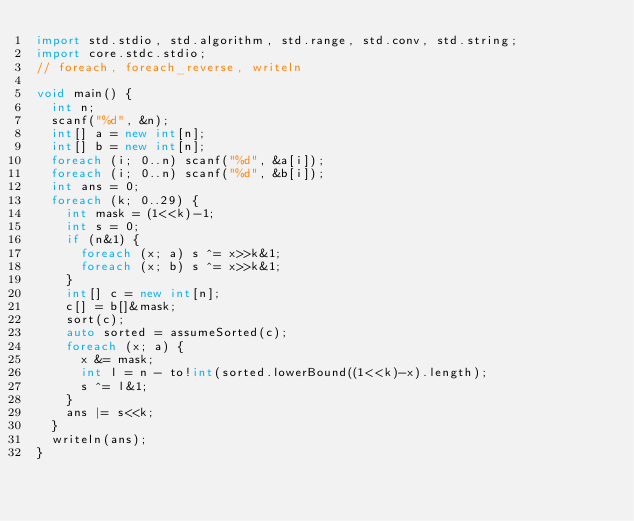Convert code to text. <code><loc_0><loc_0><loc_500><loc_500><_D_>import std.stdio, std.algorithm, std.range, std.conv, std.string;
import core.stdc.stdio;
// foreach, foreach_reverse, writeln

void main() {
	int n;
	scanf("%d", &n);
	int[] a = new int[n];
	int[] b = new int[n];
	foreach (i; 0..n) scanf("%d", &a[i]);
	foreach (i; 0..n) scanf("%d", &b[i]);
	int ans = 0;
	foreach (k; 0..29) {
		int mask = (1<<k)-1;
		int s = 0;
		if (n&1) {
			foreach (x; a) s ^= x>>k&1;
			foreach (x; b) s ^= x>>k&1;
		}
		int[] c = new int[n];
		c[] = b[]&mask;
		sort(c);
		auto sorted = assumeSorted(c);
		foreach (x; a) {
			x &= mask;
			int l = n - to!int(sorted.lowerBound((1<<k)-x).length);
			s ^= l&1;
		}
		ans |= s<<k;
	}
	writeln(ans);
}

</code> 